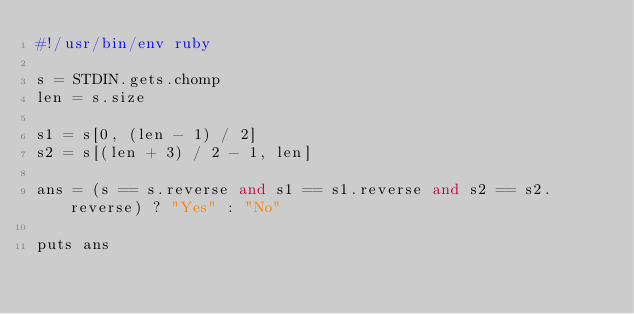<code> <loc_0><loc_0><loc_500><loc_500><_Ruby_>#!/usr/bin/env ruby

s = STDIN.gets.chomp
len = s.size

s1 = s[0, (len - 1) / 2]
s2 = s[(len + 3) / 2 - 1, len]

ans = (s == s.reverse and s1 == s1.reverse and s2 == s2.reverse) ? "Yes" : "No"

puts ans
</code> 